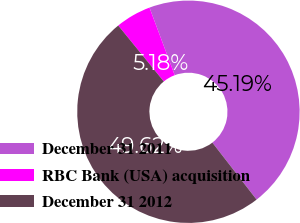<chart> <loc_0><loc_0><loc_500><loc_500><pie_chart><fcel>December 31 2011<fcel>RBC Bank (USA) acquisition<fcel>December 31 2012<nl><fcel>45.19%<fcel>5.18%<fcel>49.62%<nl></chart> 